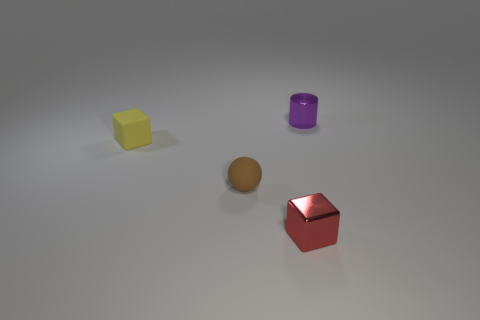Add 3 tiny yellow blocks. How many objects exist? 7 Subtract all cylinders. How many objects are left? 3 Subtract 2 cubes. How many cubes are left? 0 Subtract 0 yellow cylinders. How many objects are left? 4 Subtract all green blocks. Subtract all cyan cylinders. How many blocks are left? 2 Subtract all blue blocks. How many green balls are left? 0 Subtract all tiny gray cubes. Subtract all red shiny blocks. How many objects are left? 3 Add 2 red metal things. How many red metal things are left? 3 Add 1 metal cubes. How many metal cubes exist? 2 